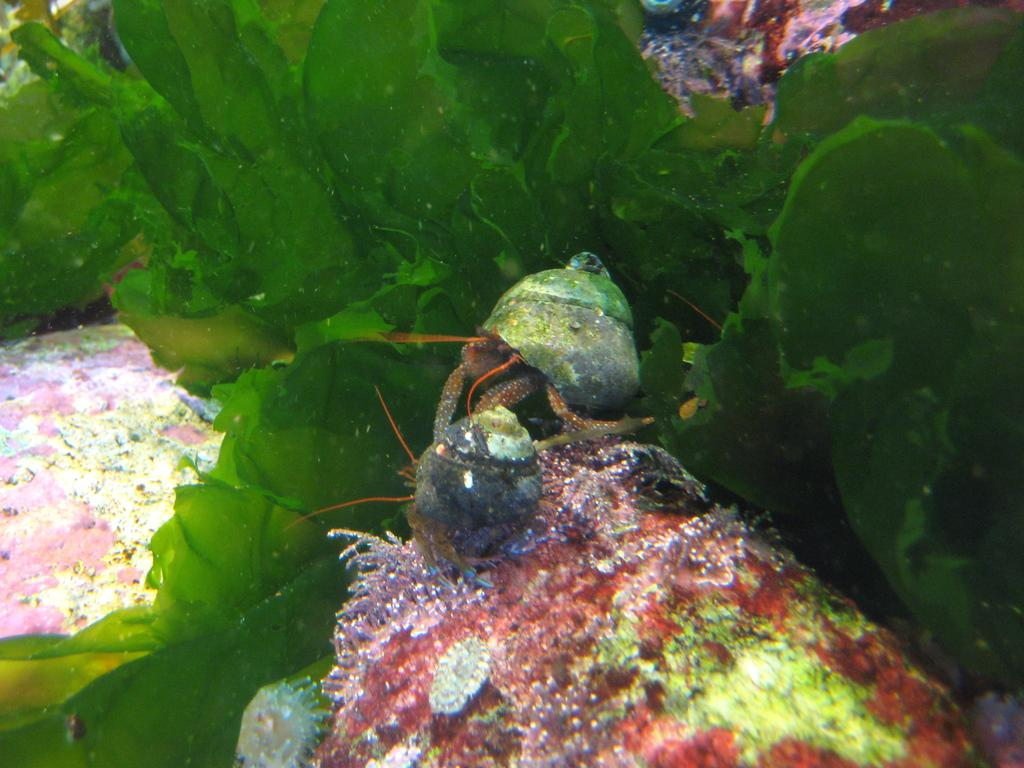What type of plants are visible in the image? There are aquatic plants in the image. What other living organisms can be seen in the image? There are aquatic animals in the image. Where might this image have been taken? The image might have been taken in an aquarium. What type of dog can be seen playing with dinosaurs in the image? There is no dog or dinosaurs present in the image; it features aquatic plants and animals. 